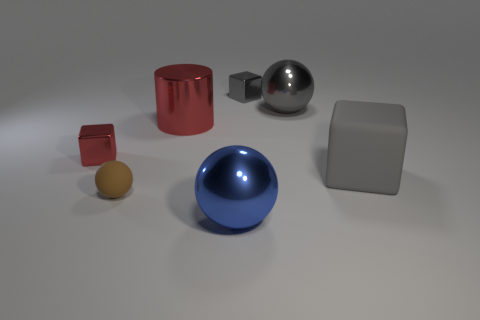Subtract all metal cubes. How many cubes are left? 1 Subtract all gray spheres. How many spheres are left? 2 Subtract all spheres. How many objects are left? 4 Subtract 0 green cubes. How many objects are left? 7 Subtract 1 balls. How many balls are left? 2 Subtract all purple cubes. Subtract all brown spheres. How many cubes are left? 3 Subtract all yellow cylinders. How many cyan blocks are left? 0 Subtract all small shiny things. Subtract all tiny gray rubber blocks. How many objects are left? 5 Add 7 big cylinders. How many big cylinders are left? 8 Add 5 purple matte cubes. How many purple matte cubes exist? 5 